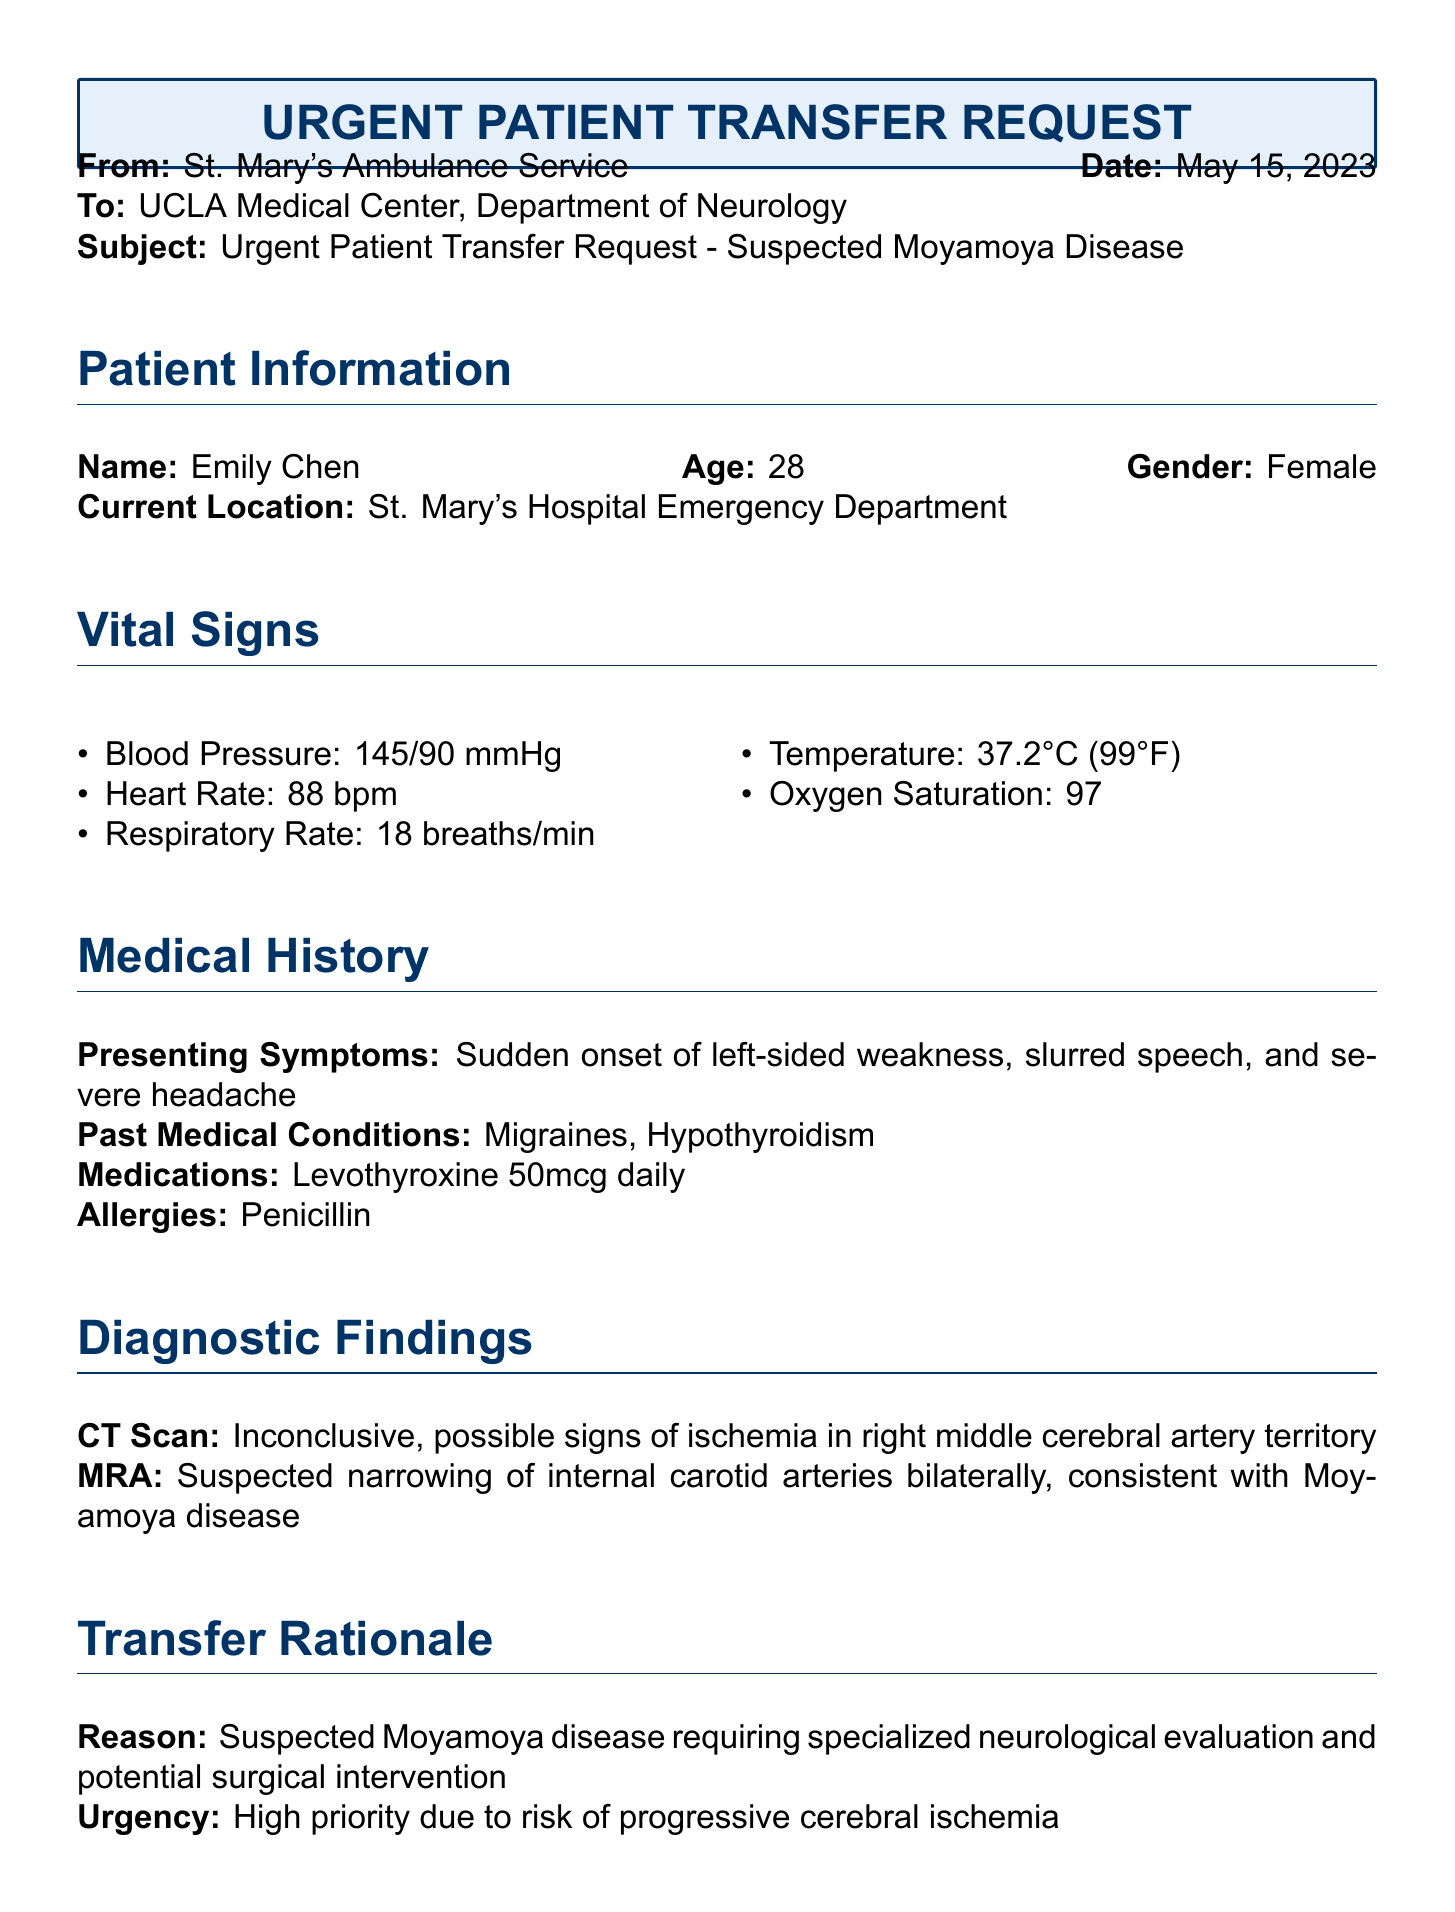what is the patient's name? The patient's name is listed under Patient Information in the document.
Answer: Emily Chen what is the age of the patient? The age of the patient is provided in the Patient Information section.
Answer: 28 what is the reason for the transfer? The reason for the transfer is mentioned in the Transfer Rationale section of the document.
Answer: Suspected Moyamoya disease requiring specialized neurological evaluation and potential surgical intervention what medications is the patient currently taking? The medications are noted in the Medical History section of the document.
Answer: Levothyroxine 50mcg daily what were the vital signs for respiratory rate? The respiratory rate is listed in the Vital Signs section.
Answer: 18 breaths/min what diagnostic findings suggest Moyamoya disease? The document states specific findings in the Diagnostic Findings section that suggest Moyamoya disease.
Answer: Suspected narrowing of internal carotid arteries bilaterally who is the referring physician? The referring physician's name is found in the Contact Information section of the document.
Answer: Dr. Sarah Johnson what is the contact number for the referring physician? The contact number is provided in the Contact Information section.
Answer: (555) 123-4567 what is the urgency level for the transfer? The urgency level is stated in the Transfer Rationale section of the document.
Answer: High priority due to risk of progressive cerebral ischemia 